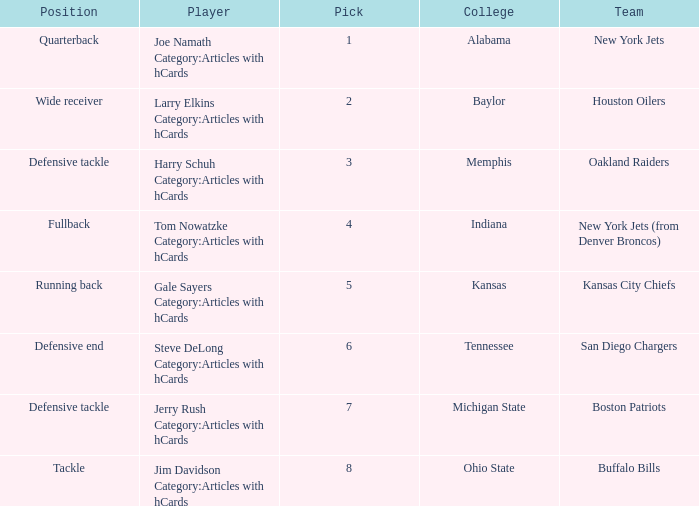Which player is from Ohio State College? Jim Davidson Category:Articles with hCards. 